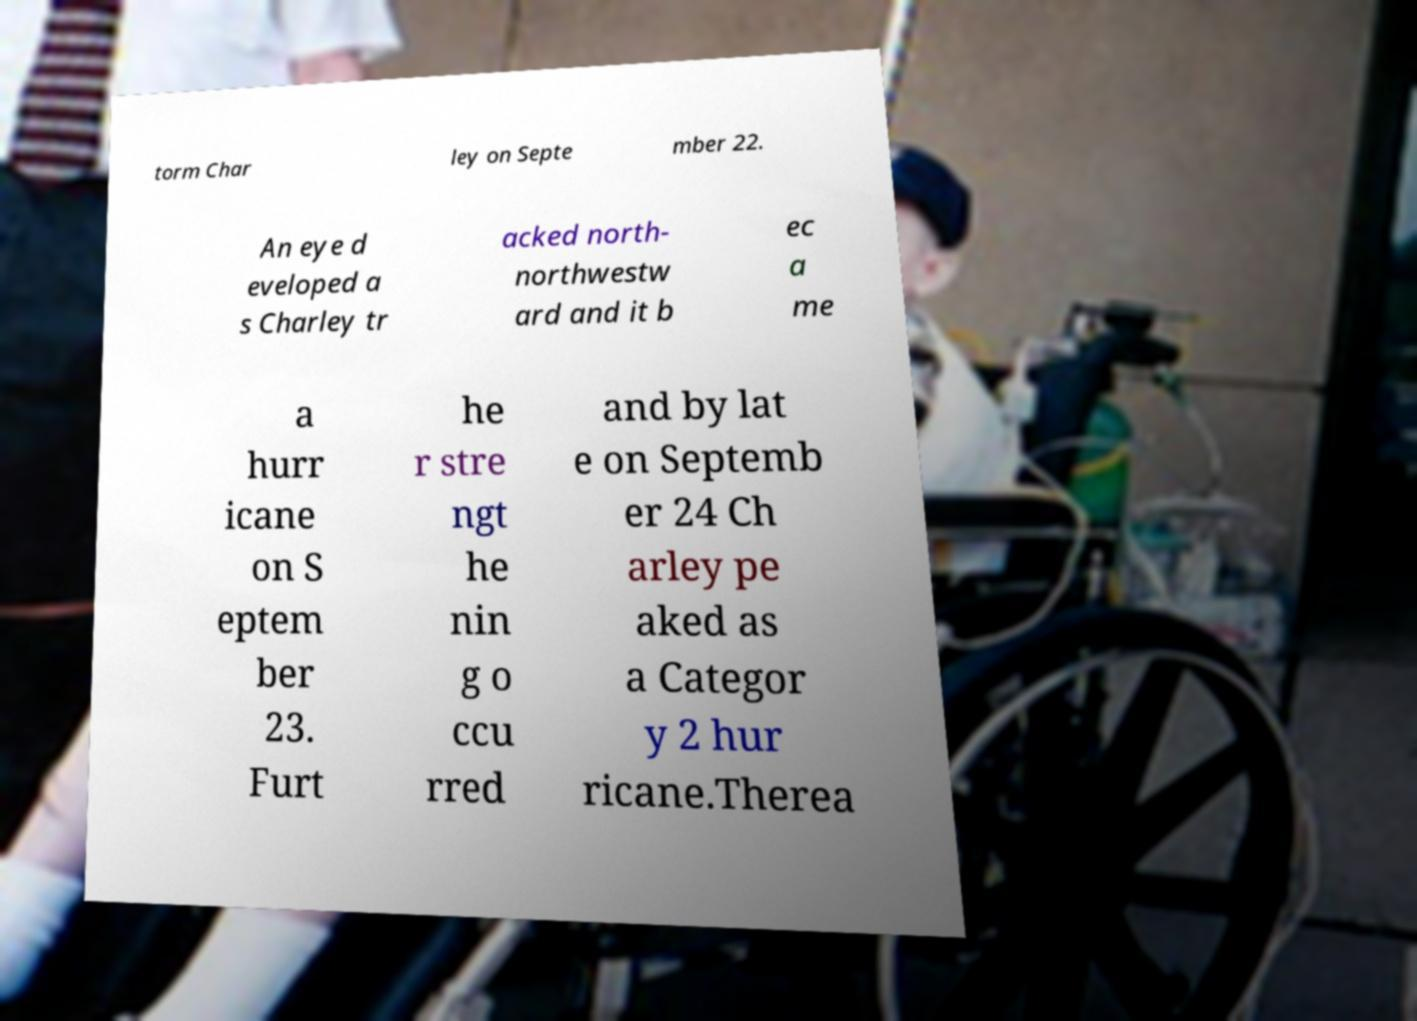There's text embedded in this image that I need extracted. Can you transcribe it verbatim? torm Char ley on Septe mber 22. An eye d eveloped a s Charley tr acked north- northwestw ard and it b ec a me a hurr icane on S eptem ber 23. Furt he r stre ngt he nin g o ccu rred and by lat e on Septemb er 24 Ch arley pe aked as a Categor y 2 hur ricane.Therea 